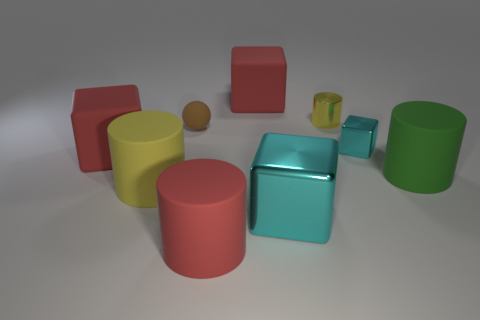Is the number of rubber balls in front of the big yellow matte cylinder the same as the number of red rubber objects?
Give a very brief answer. No. What material is the big thing to the right of the cylinder behind the small cyan cube that is on the right side of the brown rubber ball?
Your answer should be compact. Rubber. What is the color of the cylinder that is behind the big green cylinder?
Keep it short and to the point. Yellow. Is there any other thing that has the same shape as the big green rubber thing?
Your response must be concise. Yes. How big is the red matte cylinder on the left side of the cyan shiny thing that is on the right side of the tiny yellow shiny cylinder?
Keep it short and to the point. Large. Are there an equal number of rubber cylinders that are to the left of the large green cylinder and big red rubber objects that are behind the shiny cylinder?
Your response must be concise. No. What color is the sphere that is the same material as the large green object?
Your answer should be very brief. Brown. Are the large yellow object and the red cube that is in front of the tiny cyan metal thing made of the same material?
Your answer should be compact. Yes. There is a metallic thing that is both behind the large green matte cylinder and in front of the small metal cylinder; what color is it?
Offer a very short reply. Cyan. What number of spheres are large green rubber things or cyan metal objects?
Ensure brevity in your answer.  0. 